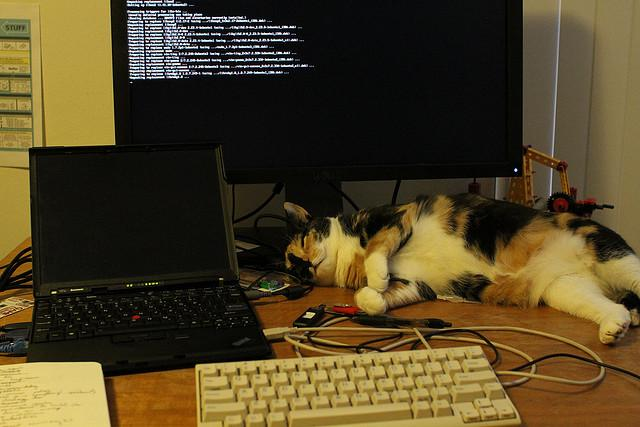What is the cat sleeping near? monitor 